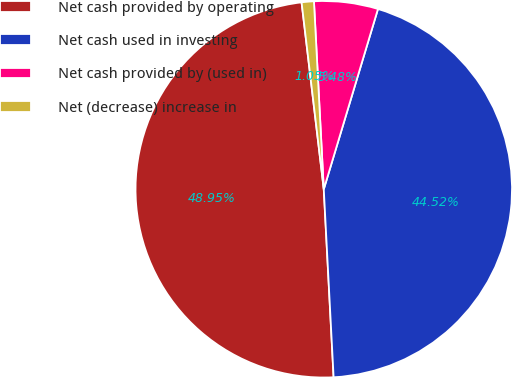Convert chart. <chart><loc_0><loc_0><loc_500><loc_500><pie_chart><fcel>Net cash provided by operating<fcel>Net cash used in investing<fcel>Net cash provided by (used in)<fcel>Net (decrease) increase in<nl><fcel>48.95%<fcel>44.52%<fcel>5.48%<fcel>1.05%<nl></chart> 